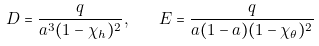<formula> <loc_0><loc_0><loc_500><loc_500>D = \frac { q } { a ^ { 3 } ( 1 - \chi _ { h } ) ^ { 2 } } , \quad E = \frac { q } { a ( 1 - a ) ( 1 - \chi _ { \theta } ) ^ { 2 } }</formula> 